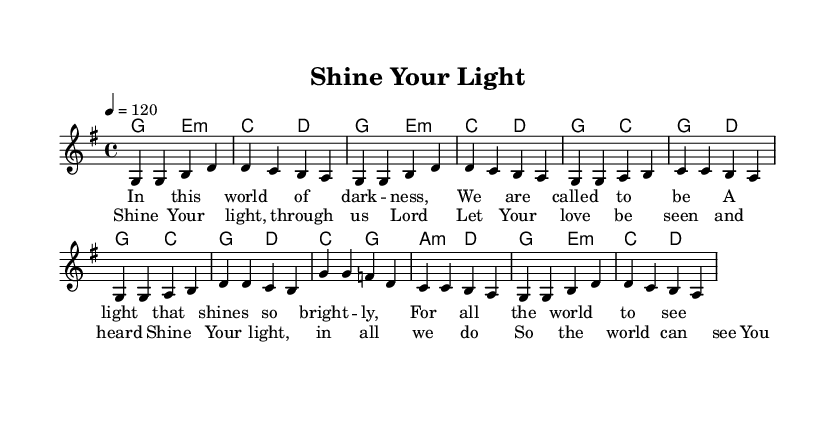What is the key signature of this music? The key signature is G major, which has one sharp. This can be identified by looking at the clef at the beginning of the staff and noting the sharp sign on the F line.
Answer: G major What is the time signature of this piece? The time signature is 4/4, which is indicated at the beginning of the score. This means there are four beats in each measure.
Answer: 4/4 What is the tempo marking for this music? The tempo marking is quarter note equals 120 beats per minute. This is derived from the tempo indication found right at the beginning of the sheet music.
Answer: 120 How many measures are in the melody? There are 10 measures in the melody section. This can be calculated by counting the individual measures marked by the vertical bar lines in the melody staff.
Answer: 10 What is the first note of the chorus? The first note of the chorus is G. This can be found by looking at the note indicated on the staff in the chorus section just after the melody ends.
Answer: G Which chord accompanies the first line of the verse? The chord is G major. This is determined by examining the chord symbols aligned above the melody in the score and focusing on the first line of the verse lyrics.
Answer: G major What is the overall theme of this piece of music? The overall theme is energetic praise and worship. This can be inferred from the title "Shine Your Light," the lyrics about being a light in the world, and the lively tempo.
Answer: Energetic praise and worship 